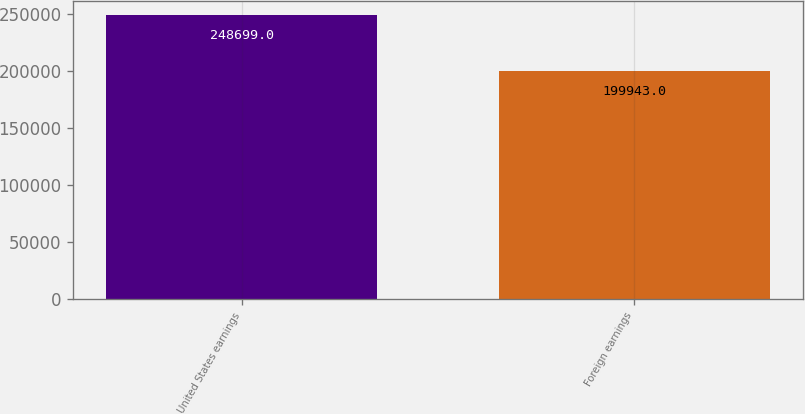Convert chart to OTSL. <chart><loc_0><loc_0><loc_500><loc_500><bar_chart><fcel>United States earnings<fcel>Foreign earnings<nl><fcel>248699<fcel>199943<nl></chart> 